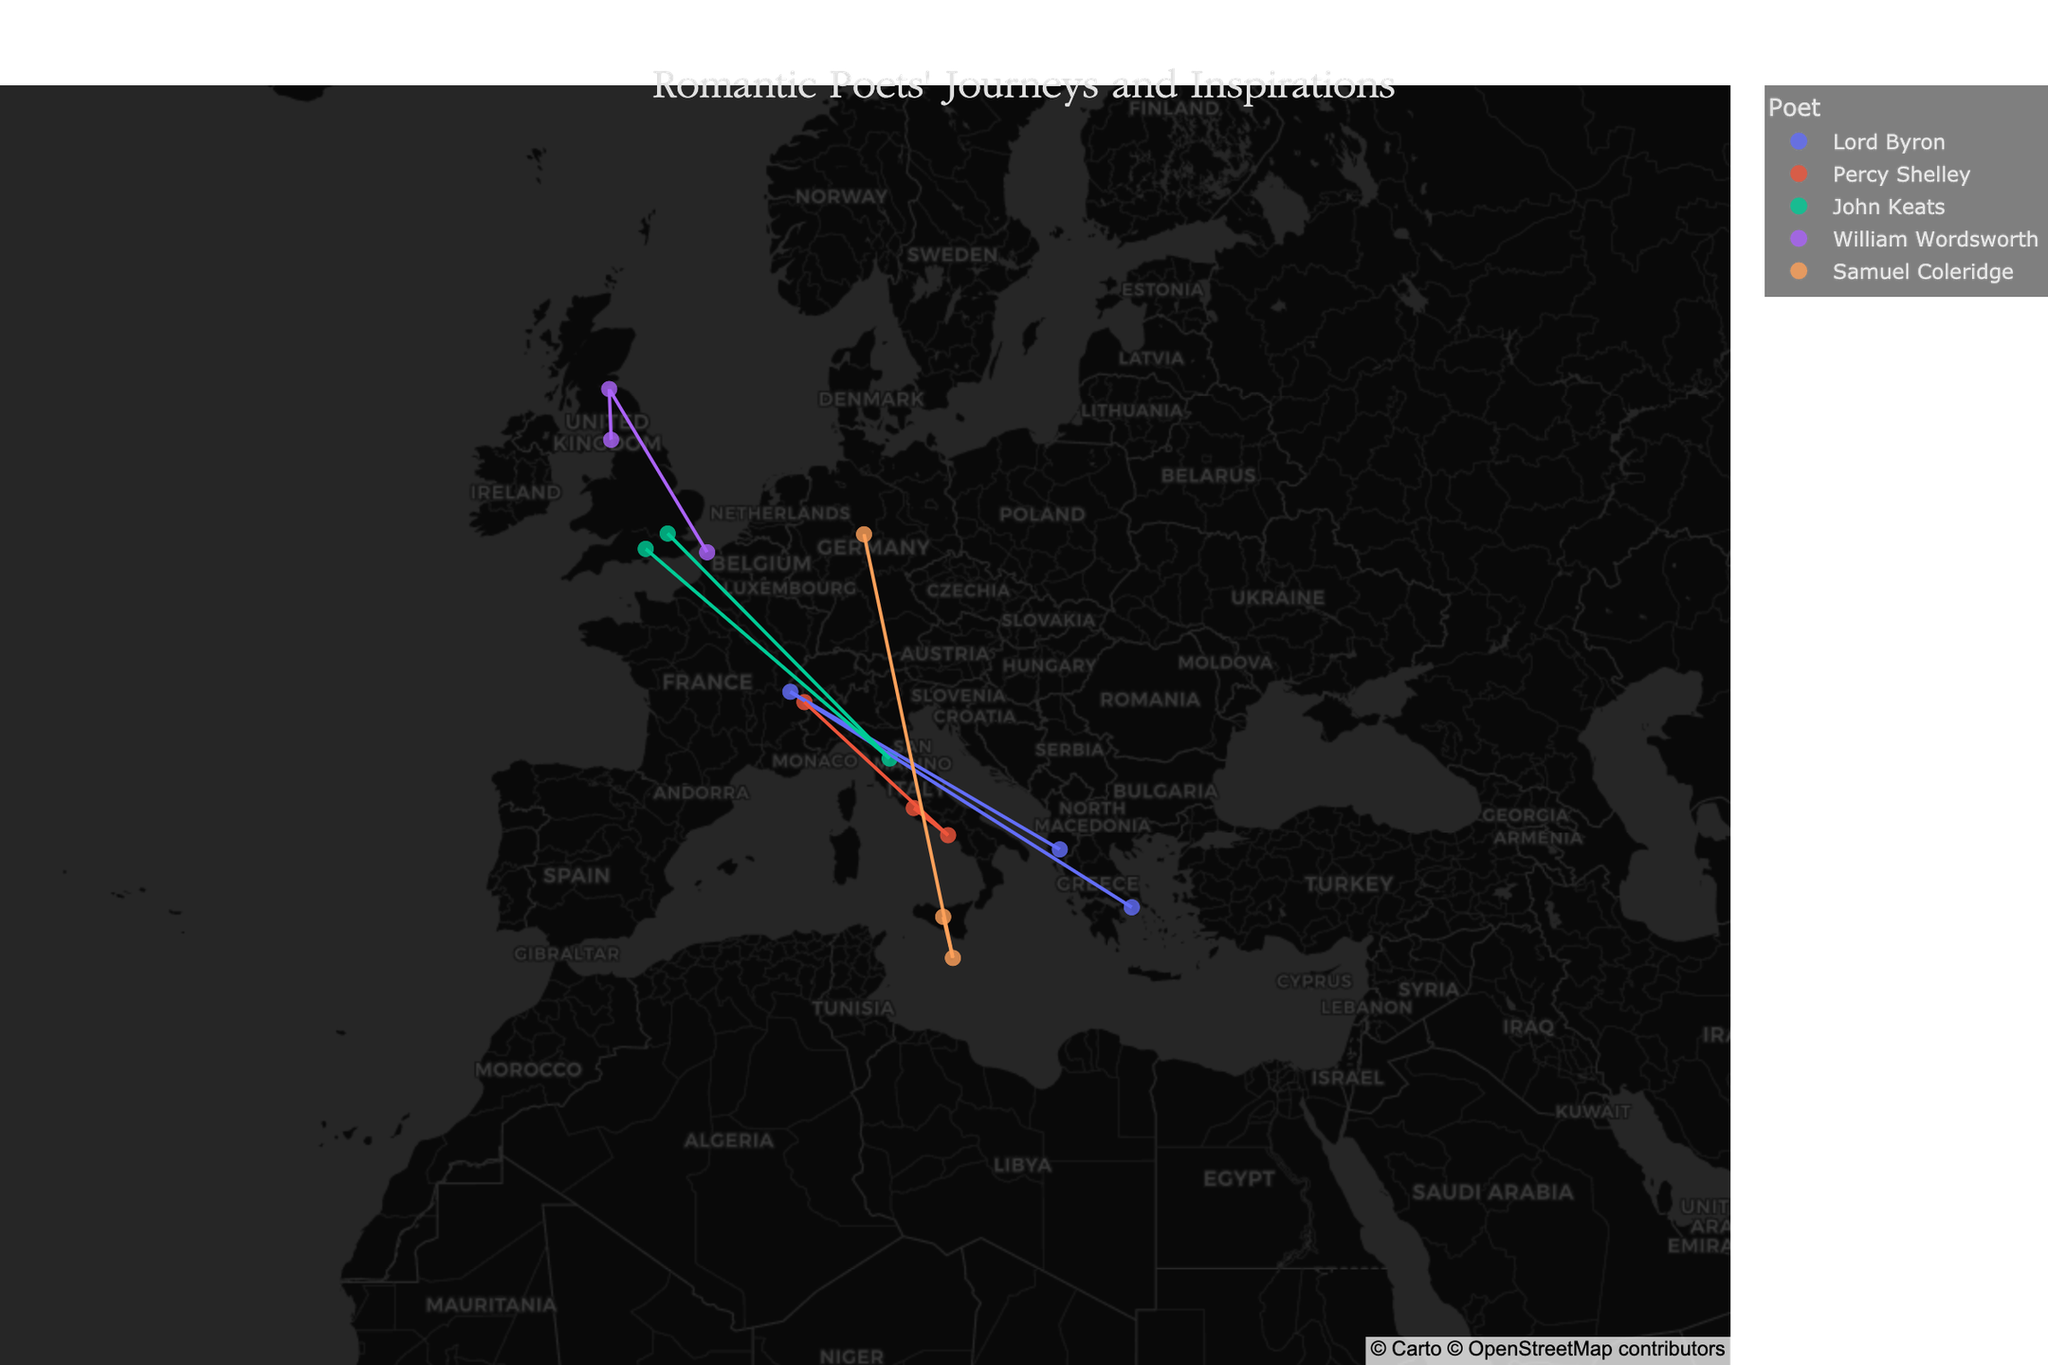What is the title of the plot? The title of a plot is usually displayed prominently at the top and is designed to provide a succinct description of the data being visualized. Here, the title is set to convey the theme of the journeys and inspirations of Romantic poets. Looking at the top of the plot, we can see the title text.
Answer: "Romantic Poets' Journeys and Inspirations" Which poet's journey includes both Switzerland and Italy? To determine this, we need to check the list of locations for each poet as represented on the map. By examining the points on the map and their corresponding labels, we can see which poets have locations in both Switzerland and Italy. Percy Shelley has locations in Mont Blanc, Switzerland, and multiple locations in Italy (Rome and Naples).
Answer: Percy Shelley How many unique cities are depicted in the plot? Each city's name is displayed on the plot. To find the number of unique cities, we count each distinct city name. From data, cities listed are Athens, Rome, Winchester, Lake District, Gottingen, Geneva, Naples, Florence, Edinburgh, Valletta, Tepelene, Mont Blanc, Hampstead, Calais, Sicily.
Answer: 15 Which country inspired John Keats with Renaissance art? Each poet's inspiration at a location is shown in the hover information. For John Keats, we check the cities and corresponding inspirations and identify that Florence, Italy is associated with Renaissance art.
Answer: Italy What are the locations in England that inspired the poets? To find this, we filter the locations by the country of England and identify the corresponding cities from the data. Based on the plot, the locations in England are Winchester, Lake District, and Hampstead.
Answer: Winchester, Lake District, Hampstead Who was influenced by German philosophy and where? Viewing the hover information for each poet, we look for the mention of German philosophy. Samuel Coleridge is inspired by German philosophy in Gottingen, Germany.
Answer: Samuel Coleridge in Gottingen Which poet has the most data points on the map? By visually inspecting the number of points for each poet and tallying them, we determine that Lord Byron has the most data points. He has three points (Athens, Geneva, Tepelene).
Answer: Lord Byron Compare the number of unique countries visited by Lord Byron and Samuel Coleridge. Who visited more? Counting the unique countries for each poet by using the color-coded points on the map, Lord Byron visited Greece, Switzerland, and Albania, while Samuel Coleridge visited Germany, Malta, and Italy. Both poets visited three unique countries.
Answer: Both visited three countries What is the primary visual style used for the map? By examining the overall appearance of the map including the background and geographical details, we see that the map uses a dark-themed visual style, specifically "carto-darkmatter," which emphasizes contrast and readability of the data points.
Answer: Dark theme (carto-darkmatter) Which city inspired poets with the grandeur of Mount Vesuvius? We observe the hover data to find which city is associated with Mount Vesuvius. The city linked to this inspiration is Naples, visited by Percy Shelley.
Answer: Naples 